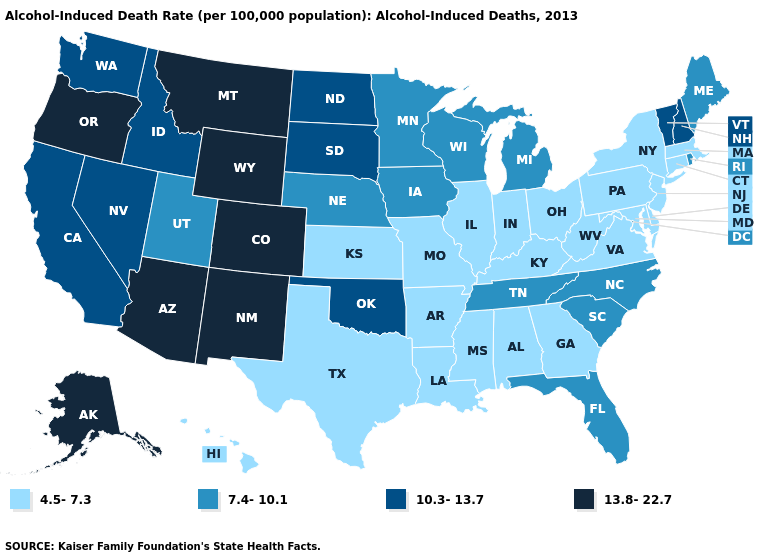Does the first symbol in the legend represent the smallest category?
Quick response, please. Yes. What is the lowest value in states that border Nebraska?
Write a very short answer. 4.5-7.3. Does Iowa have the highest value in the USA?
Keep it brief. No. Does Oklahoma have the same value as Washington?
Write a very short answer. Yes. What is the lowest value in states that border Pennsylvania?
Answer briefly. 4.5-7.3. Among the states that border Connecticut , does Rhode Island have the lowest value?
Quick response, please. No. Is the legend a continuous bar?
Answer briefly. No. What is the value of Arkansas?
Answer briefly. 4.5-7.3. Among the states that border Kentucky , which have the highest value?
Write a very short answer. Tennessee. Name the states that have a value in the range 10.3-13.7?
Be succinct. California, Idaho, Nevada, New Hampshire, North Dakota, Oklahoma, South Dakota, Vermont, Washington. Does Hawaii have the lowest value in the West?
Be succinct. Yes. Does the first symbol in the legend represent the smallest category?
Short answer required. Yes. Does Colorado have the highest value in the West?
Short answer required. Yes. Name the states that have a value in the range 10.3-13.7?
Be succinct. California, Idaho, Nevada, New Hampshire, North Dakota, Oklahoma, South Dakota, Vermont, Washington. Name the states that have a value in the range 7.4-10.1?
Be succinct. Florida, Iowa, Maine, Michigan, Minnesota, Nebraska, North Carolina, Rhode Island, South Carolina, Tennessee, Utah, Wisconsin. 